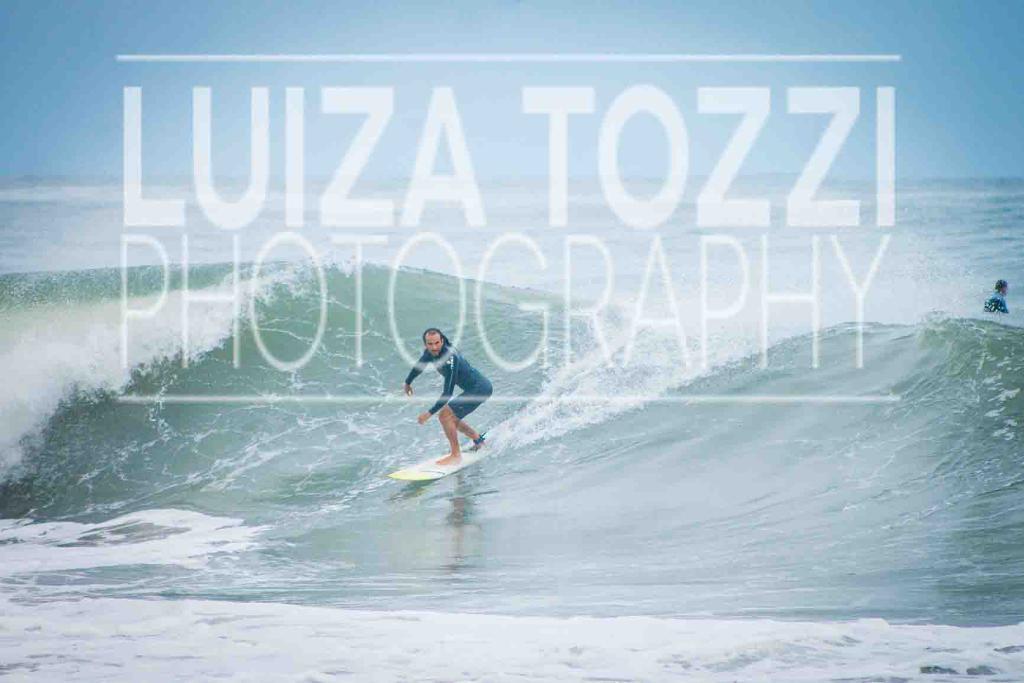How would you summarize this image in a sentence or two? In this image, we can see some water. We can also see some people. Among them, one of the persons is doing the surfing. We can also see watermark on the image. 